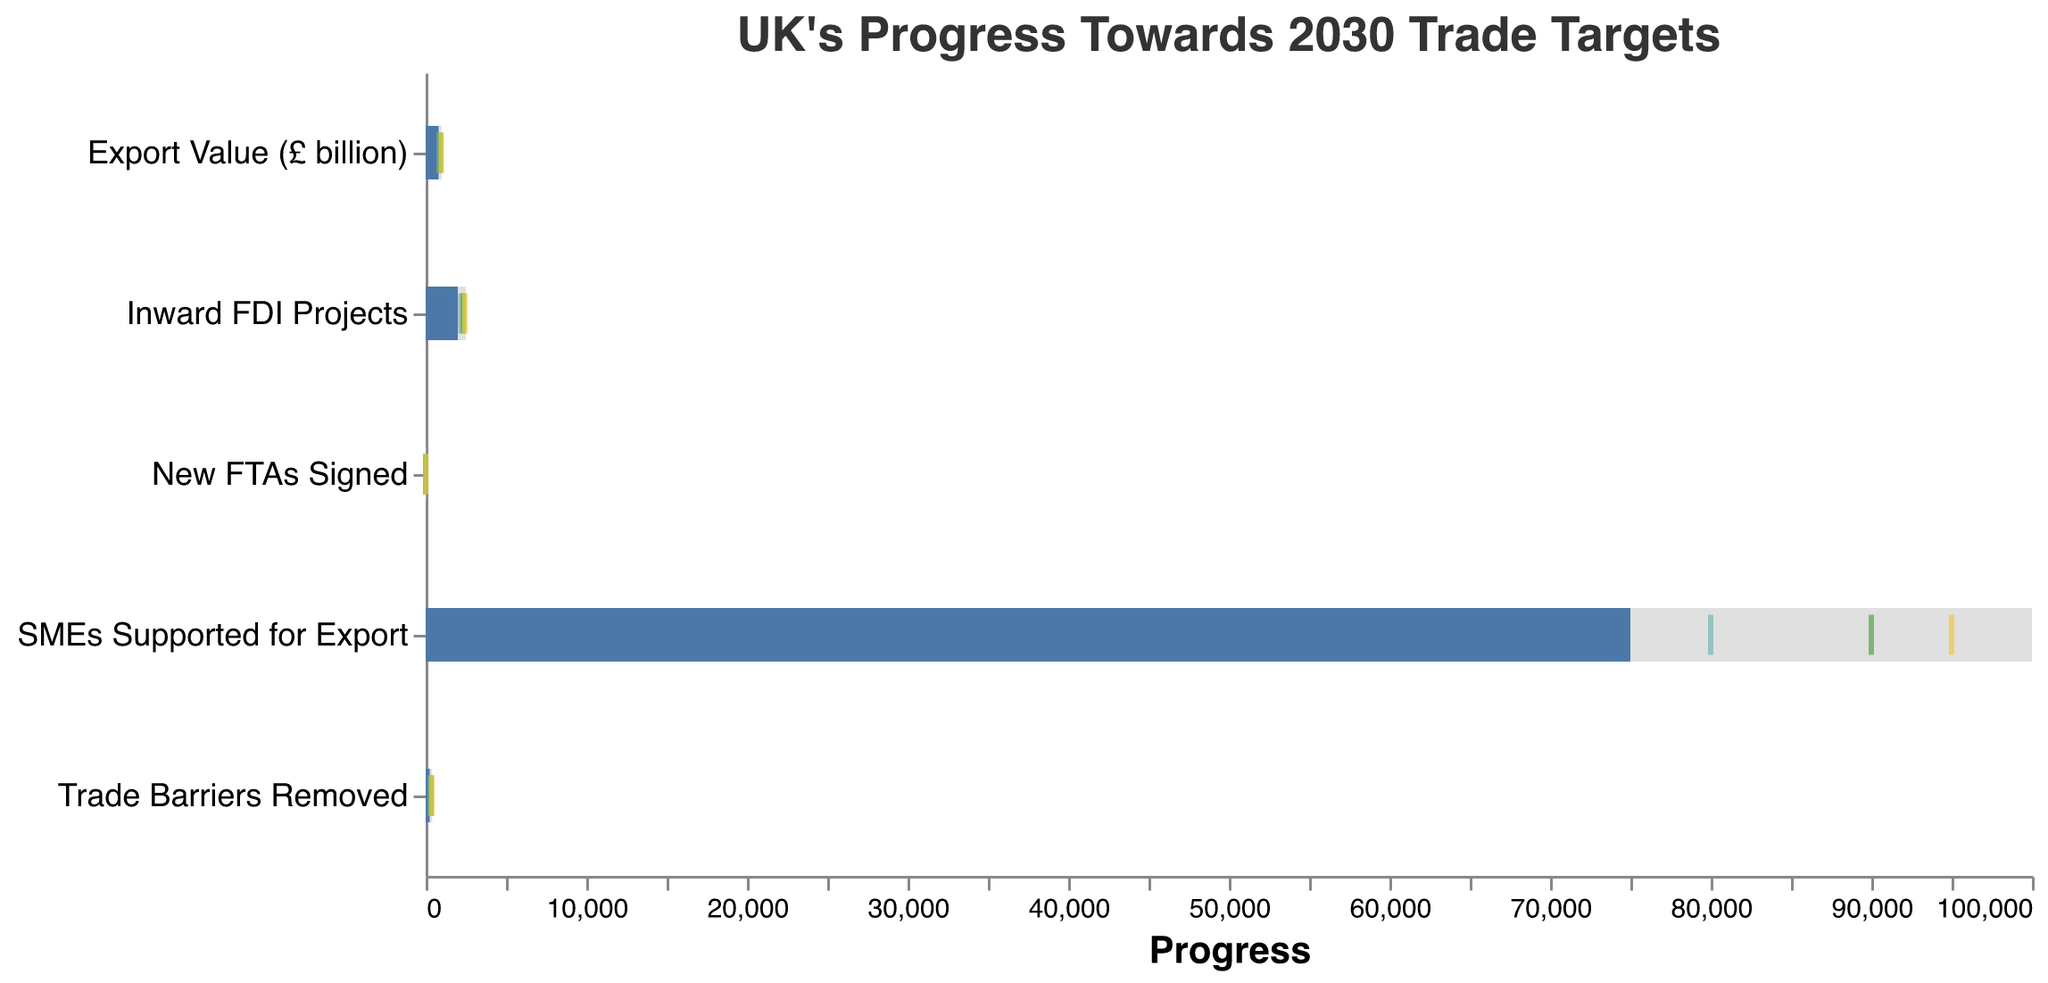What is the current export value of the UK in billion pounds? The figure includes bars indicating the "Actual" values for each category. For "Export Value (£ billion)," the bar for "Actual" shows the value directly labeled.
Answer: 800 How many new FTAs are targeted by the UK for 2030? The target values are represented by the grey bars. For "New FTAs Signed," the end of the grey bar displays the target value.
Answer: 7 By how much does the current number of trade barriers removed fall short of the 2025 milestone? To find the difference, look at the "Actual" value and the "Milestone 2025" value for "Trade Barriers Removed." Subtract the current number (250) from the 2025 milestone (300).
Answer: 50 Is the current progress for inward FDI projects ahead of the 2025 milestone? Compare the "Actual" value with the "Milestone 2025" value for the "Inward FDI Projects" category. The "Actual" value (2000) is less than the "Milestone 2025" value (2200).
Answer: No Which category is closest to achieving its 2025 milestone based on the current progress? Compare the "Actual" values with the "Milestone 2025" values for all categories. Find the category with the smallest positive difference between the "Actual" and "Milestone 2025" values.
Answer: "New FTAs Signed" How many more SMEs need to be supported to meet the 2029 milestone? Subtract the "Actual" value from the "Milestone 2029" value for "SMEs Supported for Export." The difference is 95000 - 75000.
Answer: 20000 Which milestone (2025, 2027, or 2029) has already been reached for any category? Check the "Actual" values against the milestone ticks for each year for all categories. See if any "Actual" value meets or exceeds a milestone value.
Answer: None What is the difference between the actual and target values for trade barriers removed? Subtract the "Actual" value from the "Target" value for "Trade Barriers Removed." The difference is 400 - 250.
Answer: 150 Is the current export value above or below the 2025 milestone? Compare the "Actual" value with the "Milestone 2025" value for the "Export Value (£ billion)" category. The "Actual" value (800) is less than the milestone value (850).
Answer: Below What is the average target value for all categories? Sum all the target values and divide by the number of categories. (1000 + 7 + 400 + 100000 + 2500) / 5 = 20881.4
Answer: 20881.4 